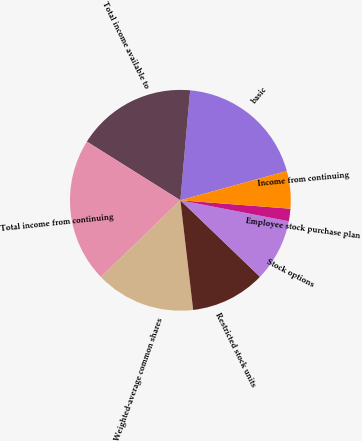Convert chart. <chart><loc_0><loc_0><loc_500><loc_500><pie_chart><fcel>basic<fcel>Total income available to<fcel>Total income from continuing<fcel>Weighted-average common shares<fcel>Restricted stock units<fcel>Stock options<fcel>Employee stock purchase plan<fcel>Income from continuing<nl><fcel>19.32%<fcel>17.49%<fcel>21.15%<fcel>14.62%<fcel>10.97%<fcel>9.14%<fcel>1.83%<fcel>5.48%<nl></chart> 